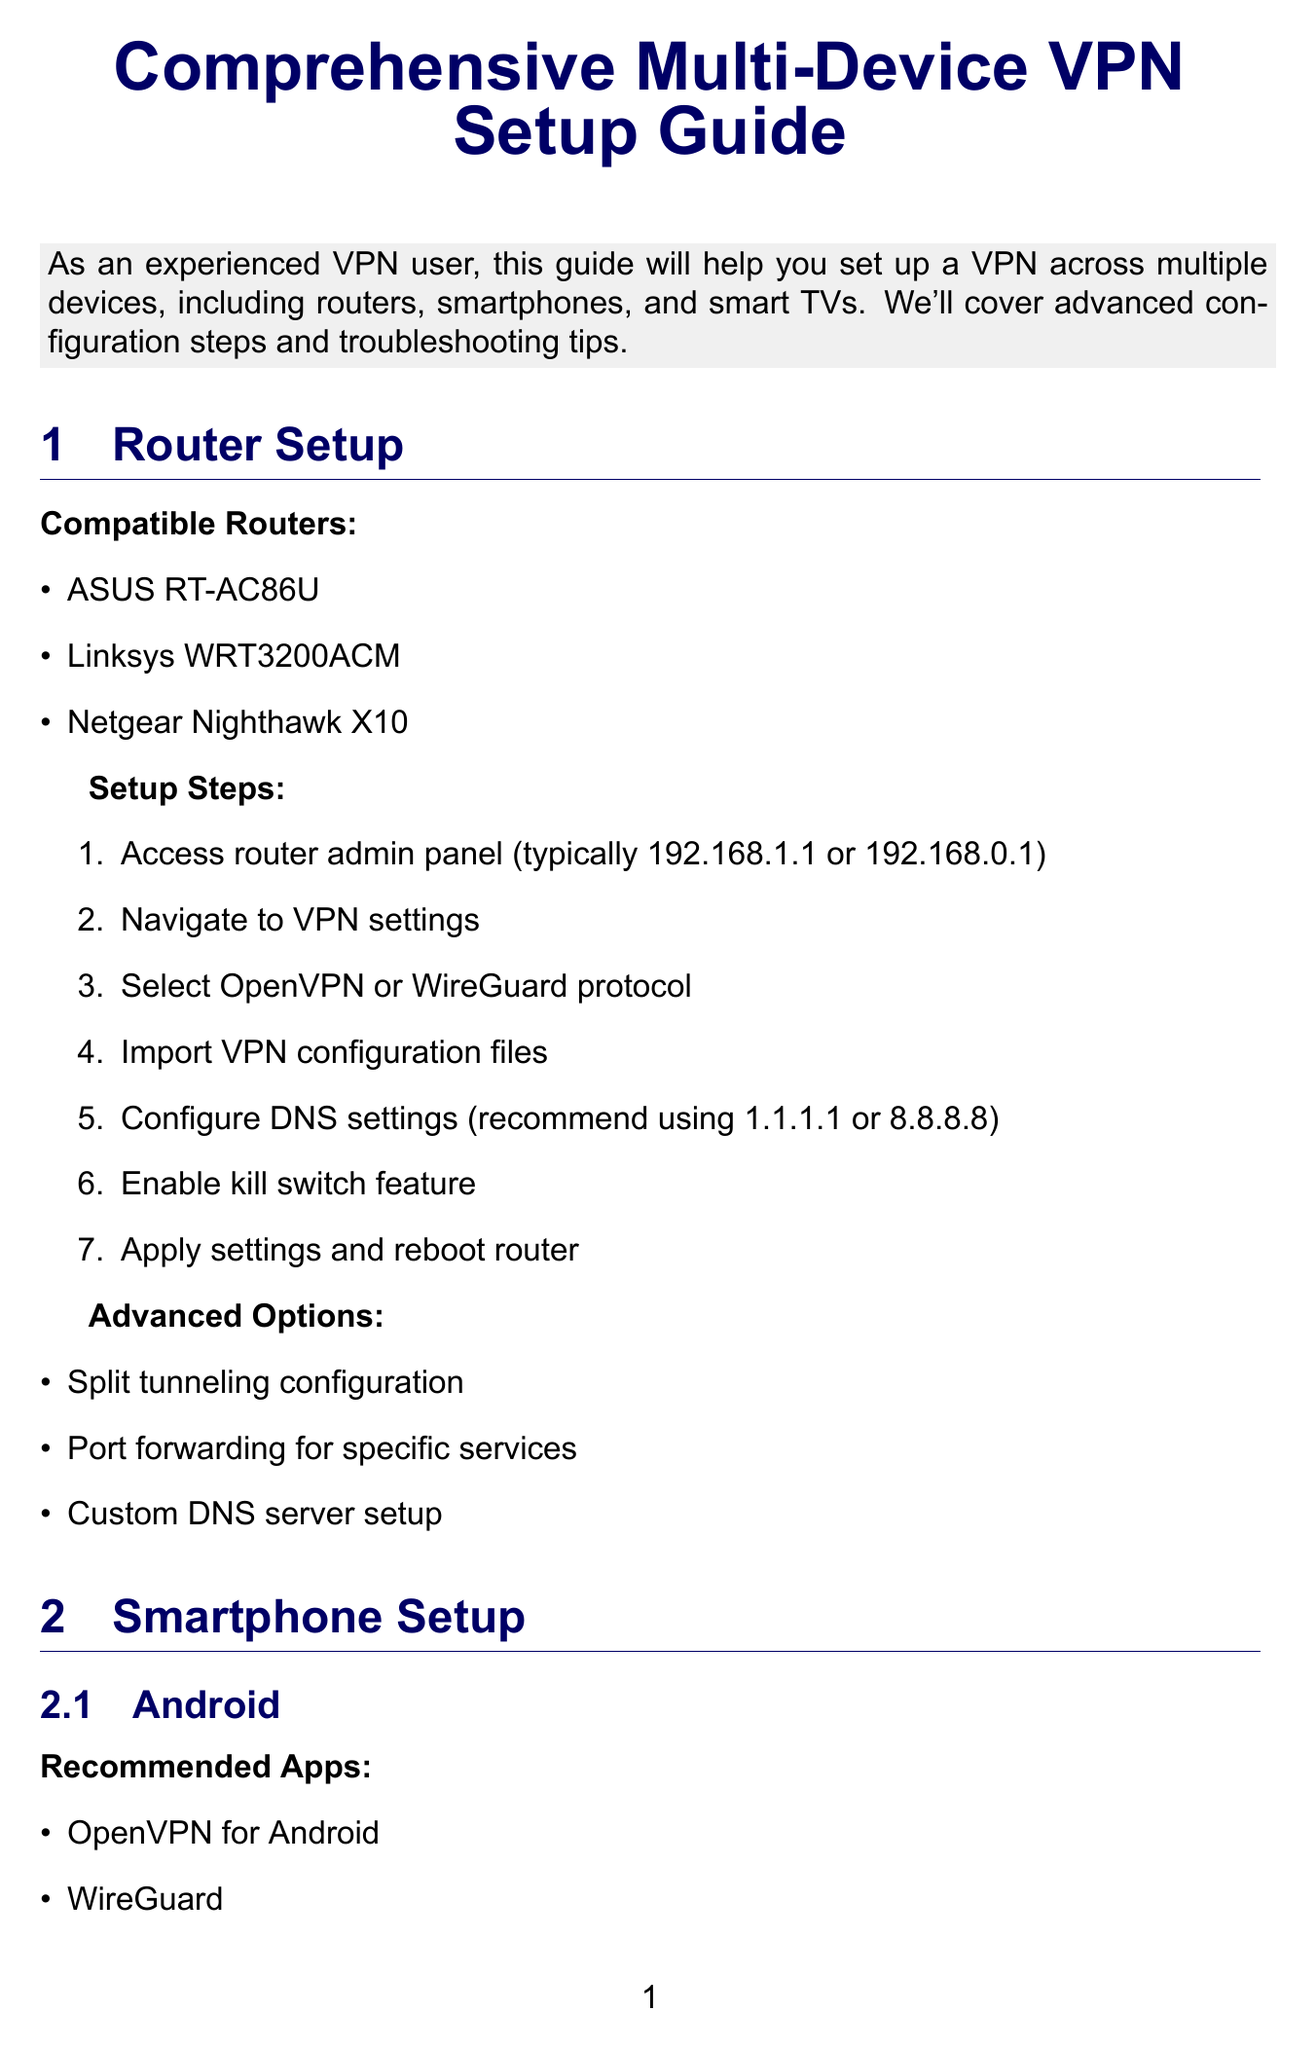what is the title of the document? The title of the document is provided at the beginning, outlined clearly in a larger font.
Answer: Comprehensive Multi-Device VPN Setup Guide how many compatible routers are listed? The document lists several compatible routers under the router setup section, which are specifically named in a bullet format.
Answer: 3 which VPN app is recommended for Android? The document specifies recommended apps for Android smartphones, presenting them in a list format for easy reference.
Answer: OpenVPN for Android what is one advanced option available for router configuration? Advanced options are provided after the basic setup steps for routers, which suggest additional features users can utilize.
Answer: Split tunneling configuration which brands are compatible with the Smart TV setup? The document lists compatible brands within the Smart TV setup section, allowing users to identify suitable devices for the VPN app.
Answer: Samsung, LG, Sony Android TV what common issue is mentioned regarding VPN use? The document highlights issues users might face while using a VPN in the troubleshooting section, specifically identifying specific problems.
Answer: Slow connection speeds what is a security tip provided in the document? Security tips are consolidated towards the end, offering users recommendations to enhance their VPN security practices.
Answer: Regularly update VPN client software which VPN provider offers Double VPN feature? The document categorizes recommended VPN providers, with specific features attributed to each, including specialized options to consider.
Answer: NordVPN what is the preferred DNS setting mentioned for routers? The document advises on DNS configurations during router setup, outlining the recommended addresses to enhance security and speed.
Answer: 1.1.1.1 or 8.8.8.8 